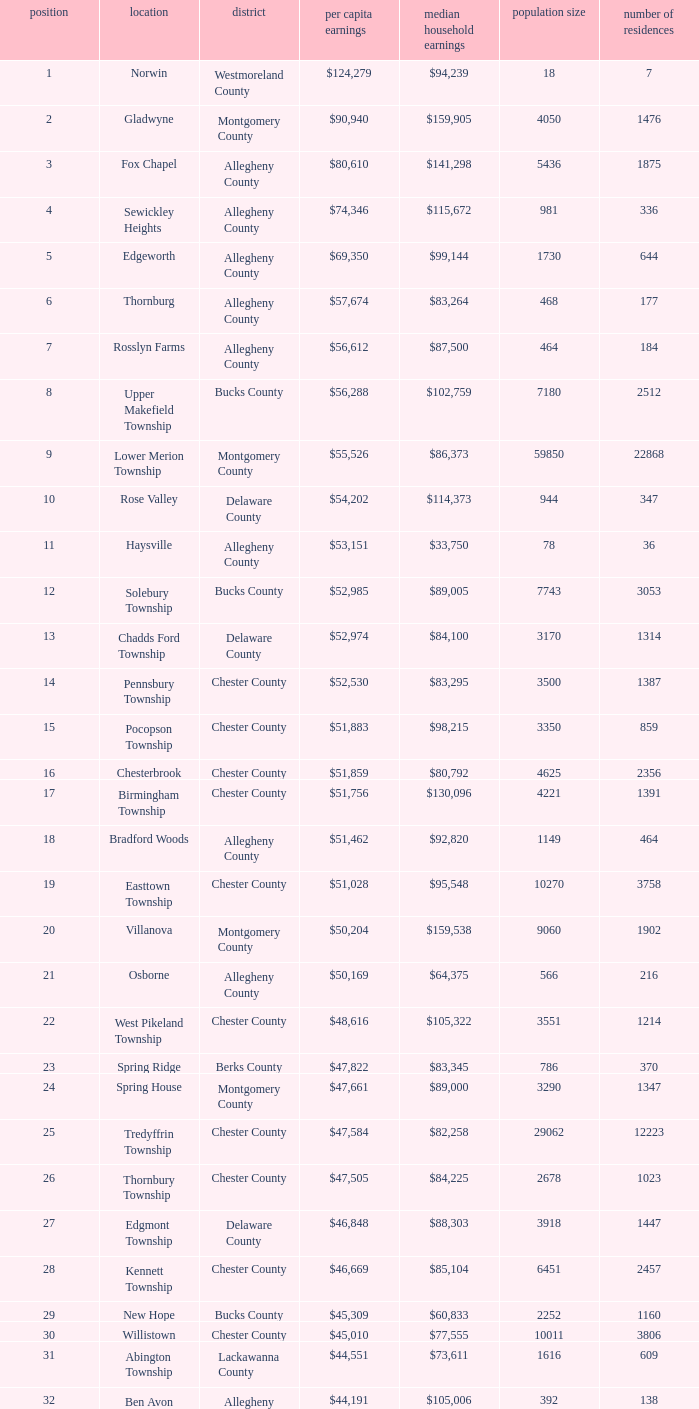What county has 2053 households?  Chester County. 